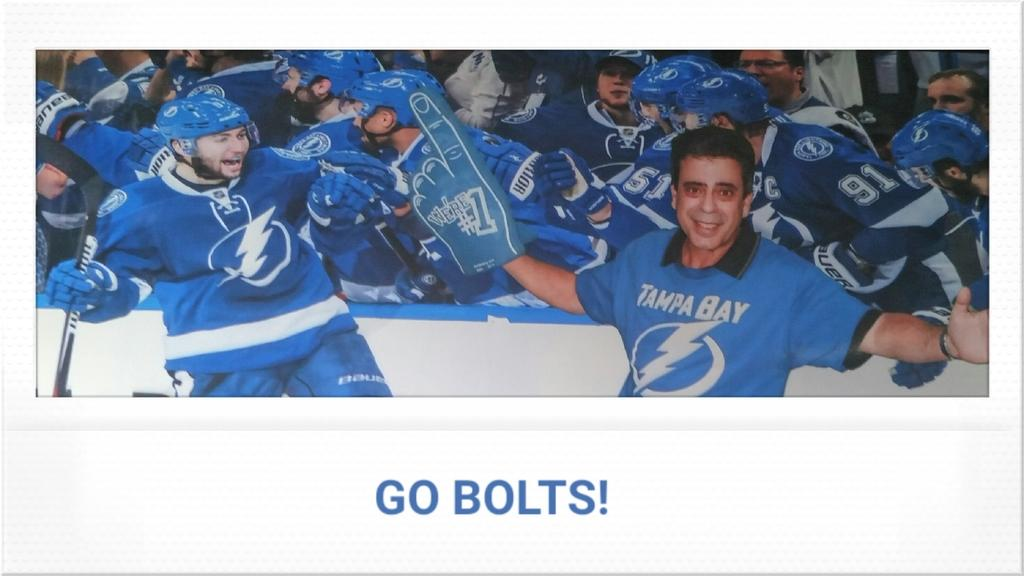<image>
Offer a succinct explanation of the picture presented. A man with a #1 thumb wearing a baby blue Tampa Bay hockey jersey poses with the team. 